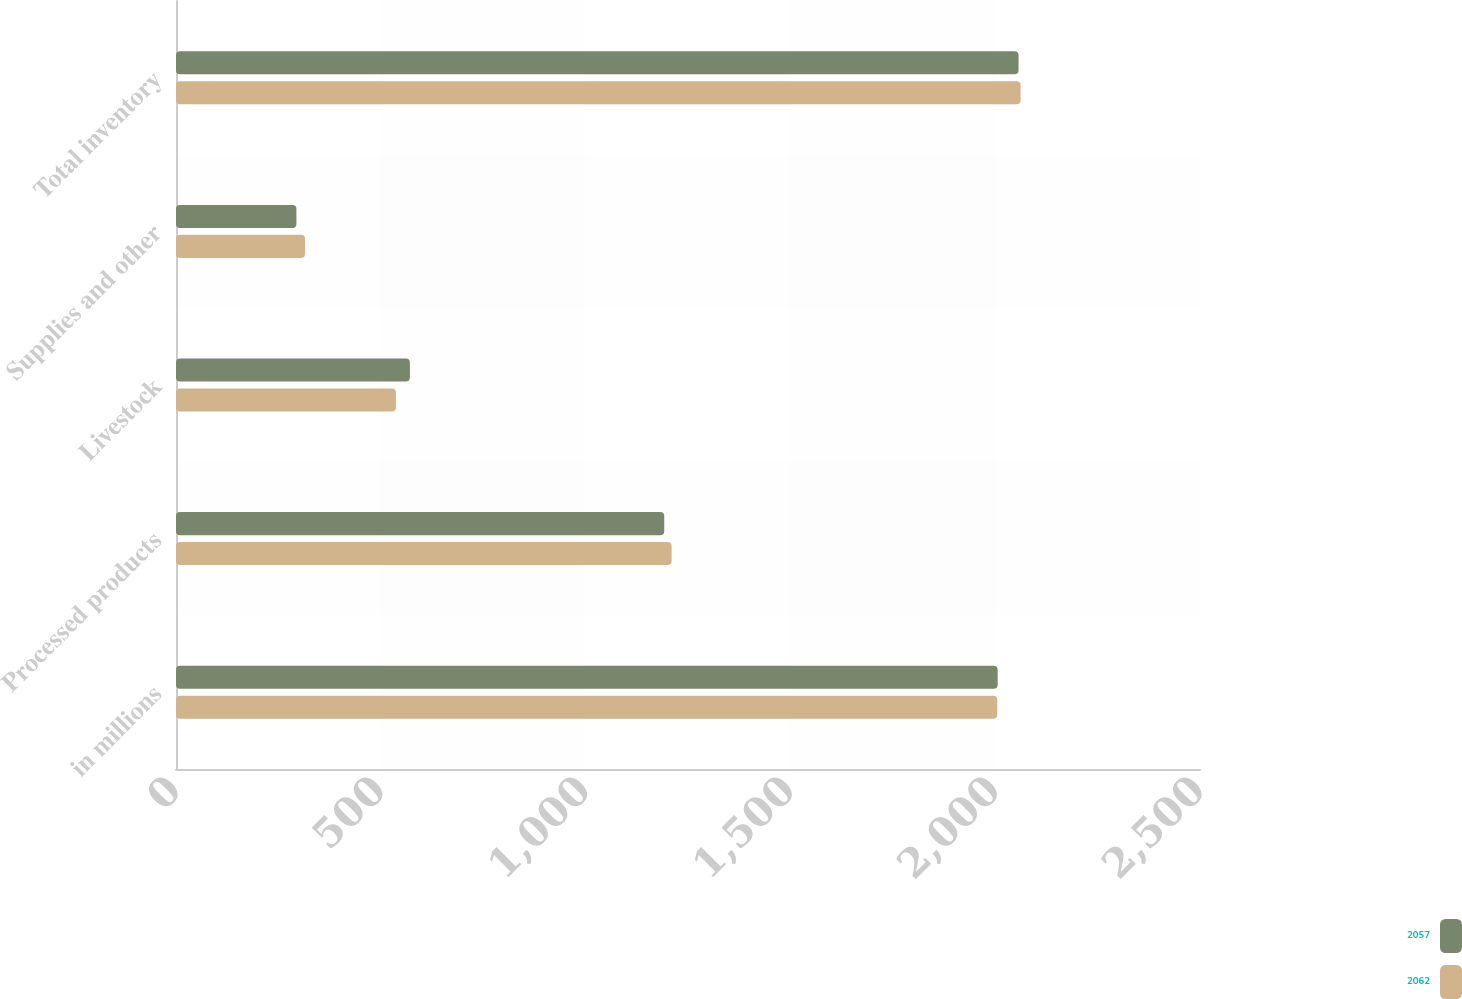Convert chart to OTSL. <chart><loc_0><loc_0><loc_500><loc_500><stacked_bar_chart><ecel><fcel>in millions<fcel>Processed products<fcel>Livestock<fcel>Supplies and other<fcel>Total inventory<nl><fcel>2057<fcel>2006<fcel>1192<fcel>571<fcel>294<fcel>2057<nl><fcel>2062<fcel>2005<fcel>1210<fcel>537<fcel>315<fcel>2062<nl></chart> 